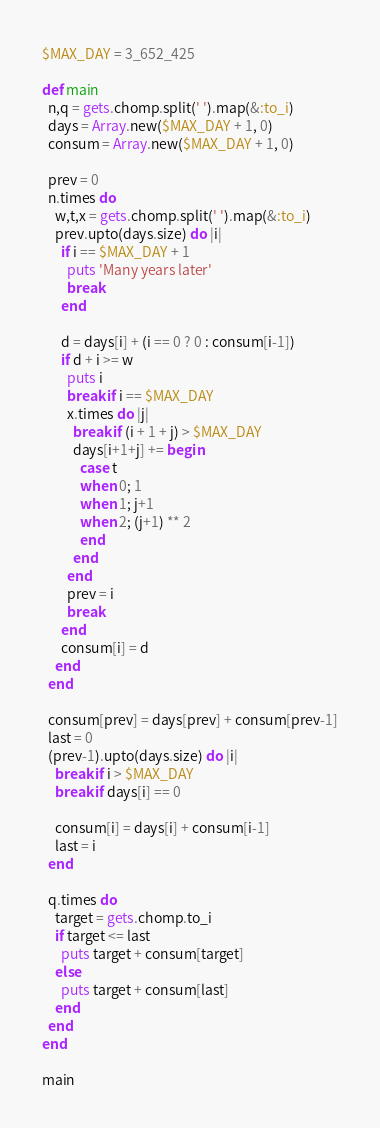Convert code to text. <code><loc_0><loc_0><loc_500><loc_500><_Ruby_>$MAX_DAY = 3_652_425

def main
  n,q = gets.chomp.split(' ').map(&:to_i)
  days = Array.new($MAX_DAY + 1, 0)
  consum = Array.new($MAX_DAY + 1, 0)

  prev = 0
  n.times do
    w,t,x = gets.chomp.split(' ').map(&:to_i)
    prev.upto(days.size) do |i|
      if i == $MAX_DAY + 1
        puts 'Many years later'
        break
      end

      d = days[i] + (i == 0 ? 0 : consum[i-1])
      if d + i >= w
        puts i
        break if i == $MAX_DAY
        x.times do |j|
          break if (i + 1 + j) > $MAX_DAY
          days[i+1+j] += begin
            case t
            when 0; 1
            when 1; j+1
            when 2; (j+1) ** 2
            end
          end
        end
        prev = i
        break
      end
      consum[i] = d
    end
  end

  consum[prev] = days[prev] + consum[prev-1]
  last = 0
  (prev-1).upto(days.size) do |i|
    break if i > $MAX_DAY
    break if days[i] == 0

    consum[i] = days[i] + consum[i-1]
    last = i
  end

  q.times do
    target = gets.chomp.to_i
    if target <= last
      puts target + consum[target]
    else
      puts target + consum[last]
    end
  end
end

main</code> 